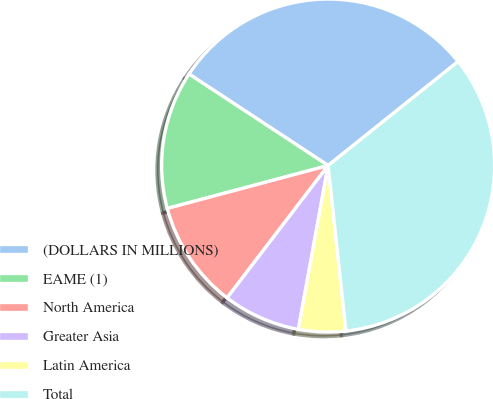Convert chart to OTSL. <chart><loc_0><loc_0><loc_500><loc_500><pie_chart><fcel>(DOLLARS IN MILLIONS)<fcel>EAME (1)<fcel>North America<fcel>Greater Asia<fcel>Latin America<fcel>Total<nl><fcel>30.0%<fcel>13.41%<fcel>10.47%<fcel>7.52%<fcel>4.57%<fcel>34.03%<nl></chart> 